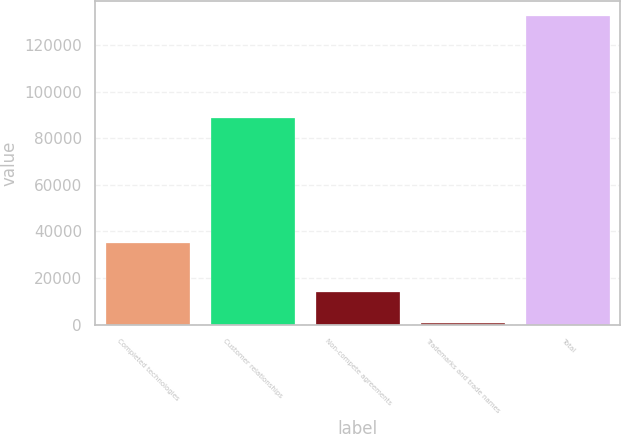Convert chart. <chart><loc_0><loc_0><loc_500><loc_500><bar_chart><fcel>Completed technologies<fcel>Customer relationships<fcel>Non-compete agreements<fcel>Trademarks and trade names<fcel>Total<nl><fcel>35031<fcel>88700<fcel>13942.1<fcel>800<fcel>132221<nl></chart> 